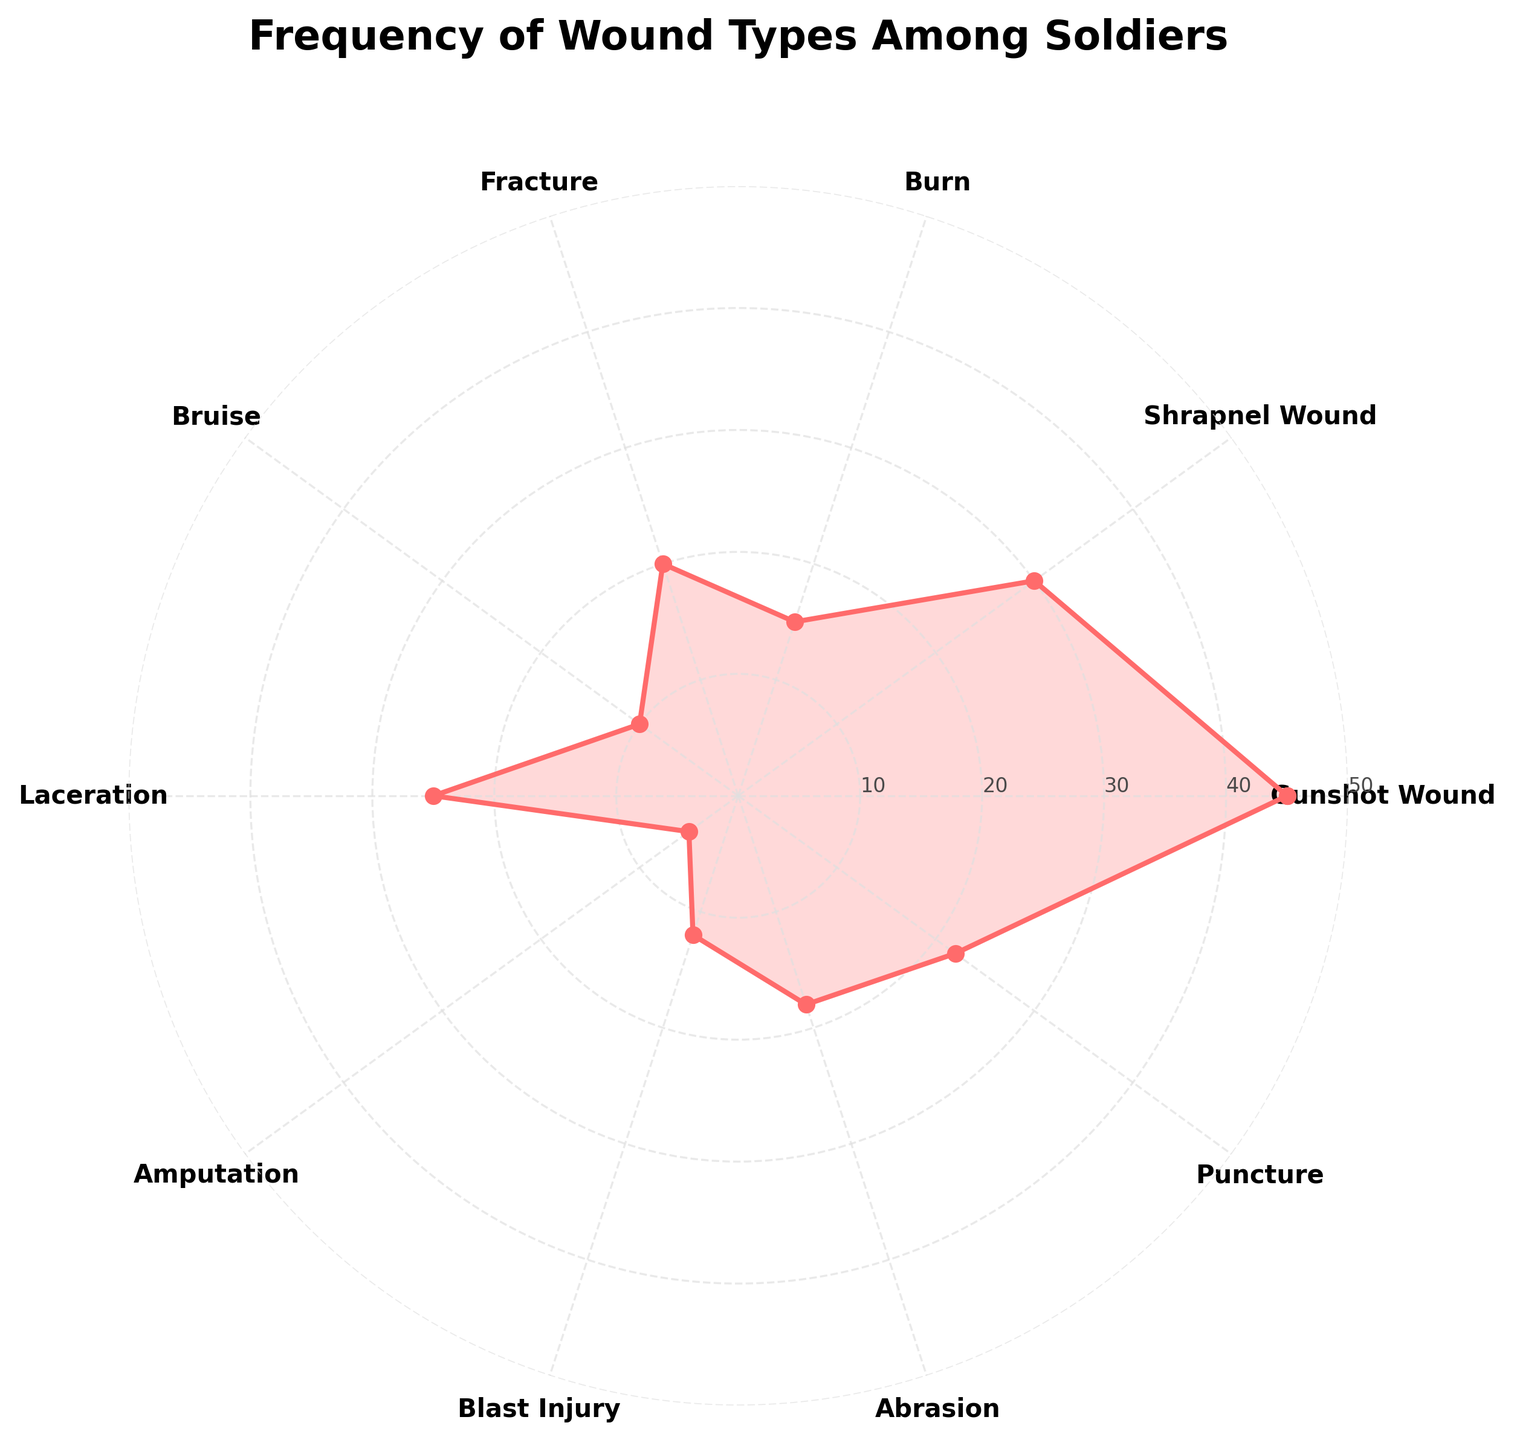What is the title of the plot? The title of the plot is typically displayed at the top center of the chart. It provides a brief description of what the plot represents. Here, it says "Frequency of Wound Types Among Soldiers".
Answer: Frequency of Wound Types Among Soldiers How many different types of wounds are presented in the figure? The number of different wound types can be counted by looking at the labels around the polar plot. Each label represents a distinct wound type.
Answer: 10 Which wound type is the most frequent among soldiers? By identifying the longest segment from the center to the edge, which corresponds to the highest value on the radial axis, we can determine the most frequent wound type. Here, it is the segment for "Gunshot Wound".
Answer: Gunshot Wound Which wound has a frequency of 20? We can find the wound type corresponding to the frequency of 20 by identifying the segment that extends to the radial tick mark labeled '20'. This wound is "Fracture".
Answer: Fracture What's the average frequency of all wound types? First, sum all frequencies: 45 (Gunshot Wound) + 30 (Shrapnel Wound) + 15 (Burn) + 20 (Fracture) + 10 (Bruise) + 25 (Laceration) + 5 (Amputation) + 12 (Blast Injury) + 18 (Abrasion) + 22 (Puncture) = 202. Then divide by the number of wound types, which is 10: 202/10 = 20.2.
Answer: 20.2 How many wound types have a frequency greater than 20? By examining the plot, count the number of segments that extend beyond the radial axis tick mark labeled '20'. The wound types are Gunshot Wound, Shrapnel Wound, Laceration, and Puncture: a total of 4 wound types.
Answer: 4 Which is less frequent, 'Blast Injury' or 'Abrasion'? By comparing the lengths of the segments corresponding to 'Blast Injury' (12) and 'Abrasion' (18), we observe that the segment for 'Blast Injury' is shorter, indicating it is less frequent.
Answer: Blast Injury What is the combined frequency of 'Amputation' and 'Bruise'? The frequencies of 'Amputation' and 'Bruise' are 5 and 10 respectively. Adding these frequencies together gives 5 + 10 = 15.
Answer: 15 Are there any wound types with the same frequency? By checking and comparing the lengths of each segment, we find that no two wound segments share the exact same length, indicating no two wound types have the same frequency.
Answer: No What is the difference in frequency between the most frequent and the least frequent wound types? The most frequent wound type is 'Gunshot Wound' with a frequency of 45, and the least frequent wound type is 'Amputation' with a frequency of 5. The difference is 45 - 5 = 40.
Answer: 40 